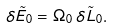Convert formula to latex. <formula><loc_0><loc_0><loc_500><loc_500>\delta \tilde { E } _ { 0 } = \Omega _ { 0 } \, \delta \tilde { L } _ { 0 } .</formula> 